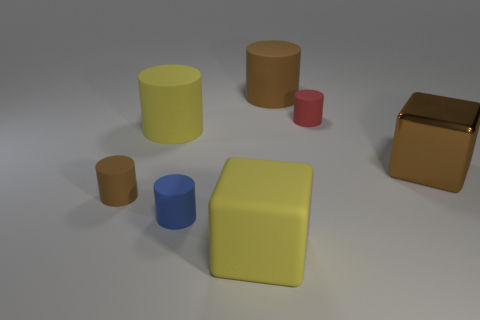Is there anything else that is the same material as the large brown block?
Ensure brevity in your answer.  No. Does the small blue matte thing that is in front of the brown shiny cube have the same shape as the big brown matte thing?
Keep it short and to the point. Yes. How many small cyan metal cylinders are there?
Offer a terse response. 0. How many brown rubber things are the same size as the blue rubber object?
Ensure brevity in your answer.  1. What is the material of the blue cylinder?
Keep it short and to the point. Rubber. There is a matte cube; is its color the same as the big rubber object left of the yellow matte block?
Your response must be concise. Yes. There is a object that is right of the big brown rubber cylinder and behind the brown shiny cube; what size is it?
Ensure brevity in your answer.  Small. There is a big yellow object that is made of the same material as the big yellow cylinder; what is its shape?
Your answer should be very brief. Cube. Do the large brown cylinder and the small object behind the brown block have the same material?
Offer a very short reply. Yes. Are there any large matte objects that are to the left of the brown thing behind the tiny red object?
Provide a succinct answer. Yes. 